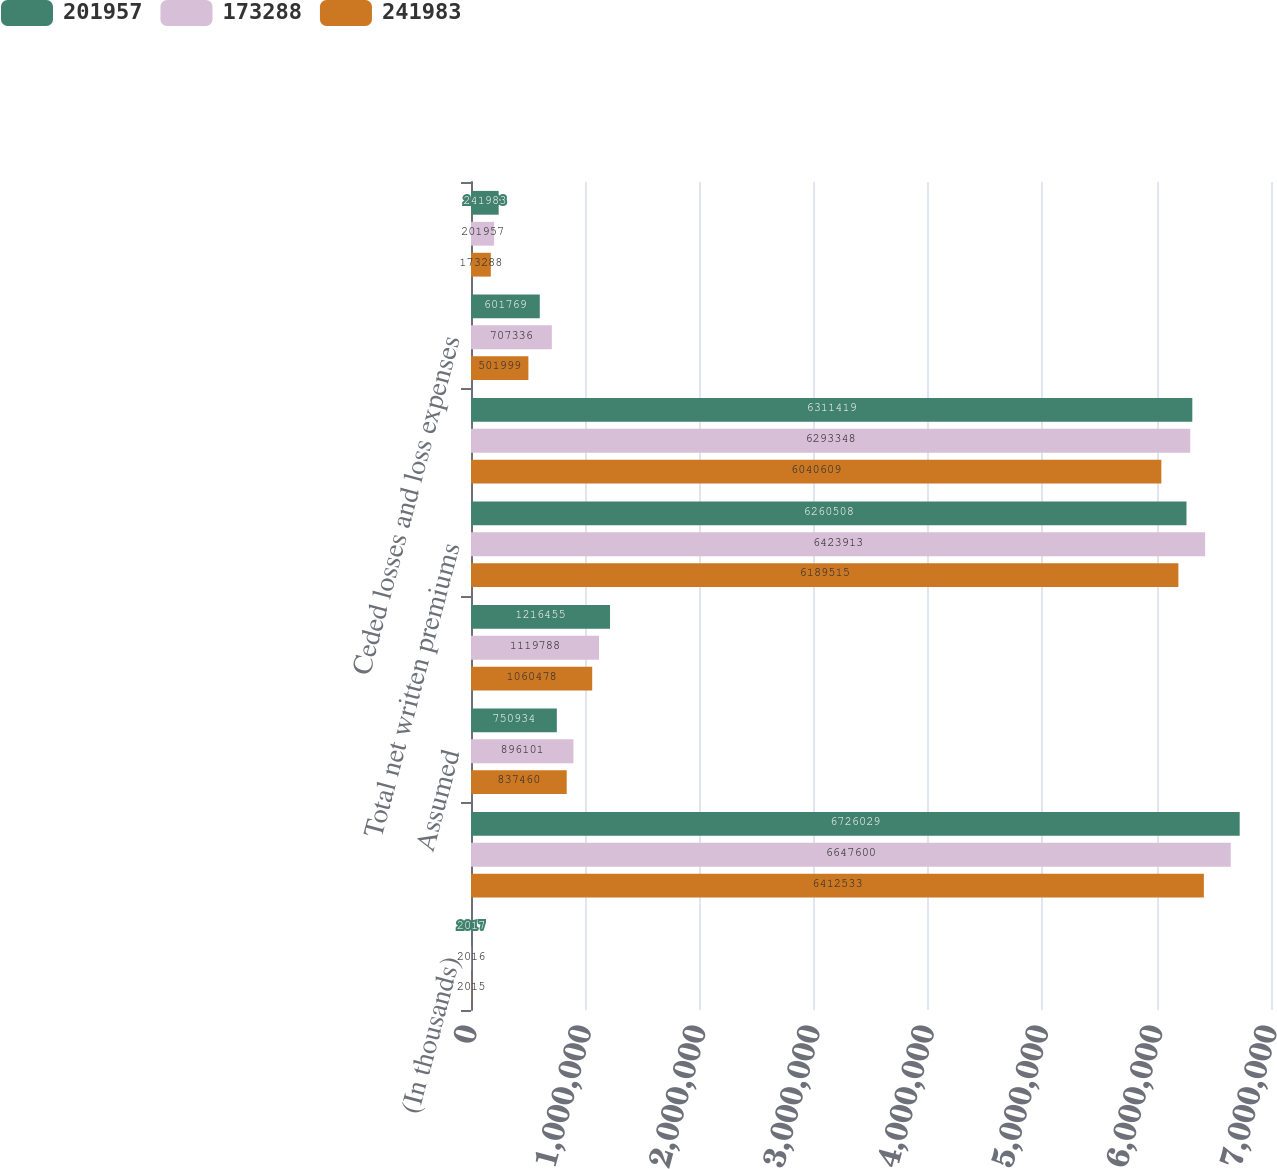Convert chart. <chart><loc_0><loc_0><loc_500><loc_500><stacked_bar_chart><ecel><fcel>(In thousands)<fcel>Direct<fcel>Assumed<fcel>Ceded<fcel>Total net written premiums<fcel>Total net earned premiums<fcel>Ceded losses and loss expenses<fcel>Ceded commission earned<nl><fcel>201957<fcel>2017<fcel>6.72603e+06<fcel>750934<fcel>1.21646e+06<fcel>6.26051e+06<fcel>6.31142e+06<fcel>601769<fcel>241983<nl><fcel>173288<fcel>2016<fcel>6.6476e+06<fcel>896101<fcel>1.11979e+06<fcel>6.42391e+06<fcel>6.29335e+06<fcel>707336<fcel>201957<nl><fcel>241983<fcel>2015<fcel>6.41253e+06<fcel>837460<fcel>1.06048e+06<fcel>6.18952e+06<fcel>6.04061e+06<fcel>501999<fcel>173288<nl></chart> 